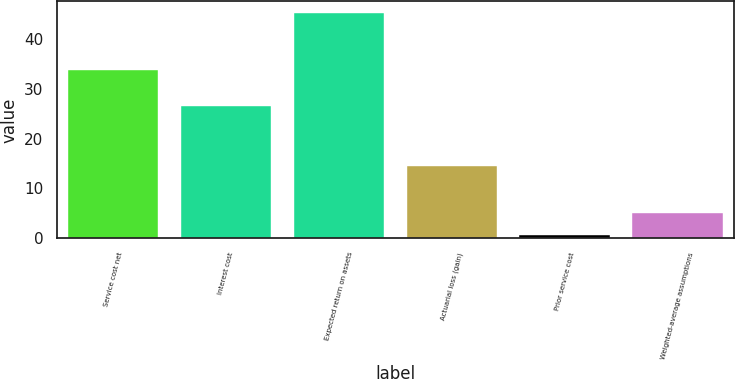<chart> <loc_0><loc_0><loc_500><loc_500><bar_chart><fcel>Service cost net<fcel>Interest cost<fcel>Expected return on assets<fcel>Actuarial loss (gain)<fcel>Prior service cost<fcel>Weighted-average assumptions<nl><fcel>33.8<fcel>26.6<fcel>45.2<fcel>14.5<fcel>0.7<fcel>5.15<nl></chart> 